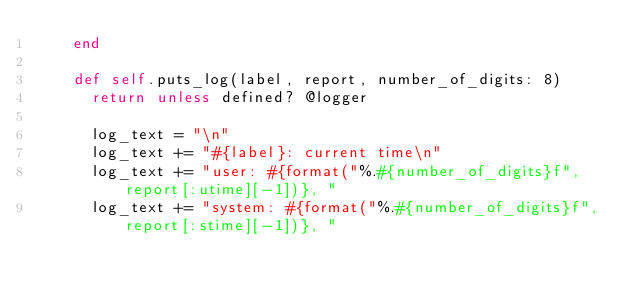Convert code to text. <code><loc_0><loc_0><loc_500><loc_500><_Ruby_>    end

    def self.puts_log(label, report, number_of_digits: 8)
      return unless defined? @logger

      log_text = "\n"
      log_text += "#{label}: current time\n"
      log_text += "user: #{format("%.#{number_of_digits}f", report[:utime][-1])}, "
      log_text += "system: #{format("%.#{number_of_digits}f", report[:stime][-1])}, "</code> 